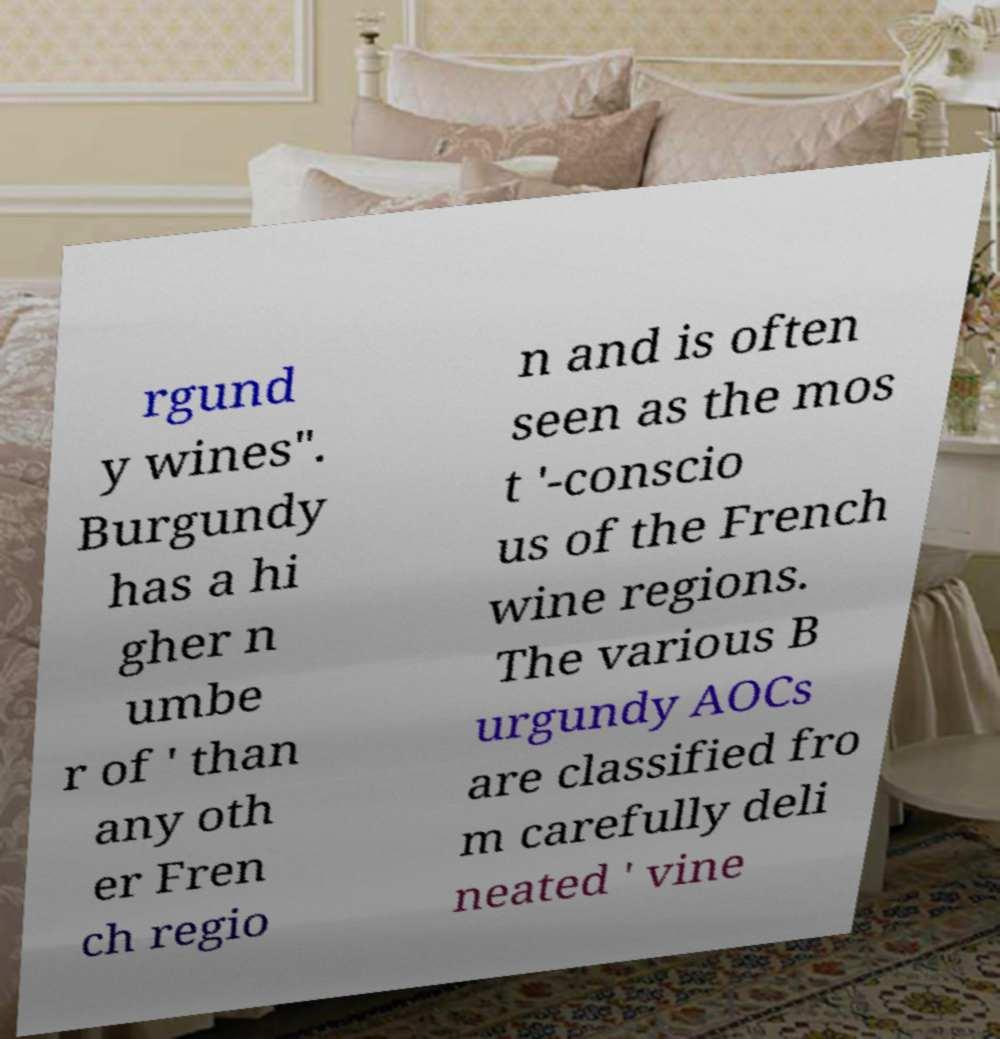Please identify and transcribe the text found in this image. rgund y wines". Burgundy has a hi gher n umbe r of ' than any oth er Fren ch regio n and is often seen as the mos t '-conscio us of the French wine regions. The various B urgundy AOCs are classified fro m carefully deli neated ' vine 